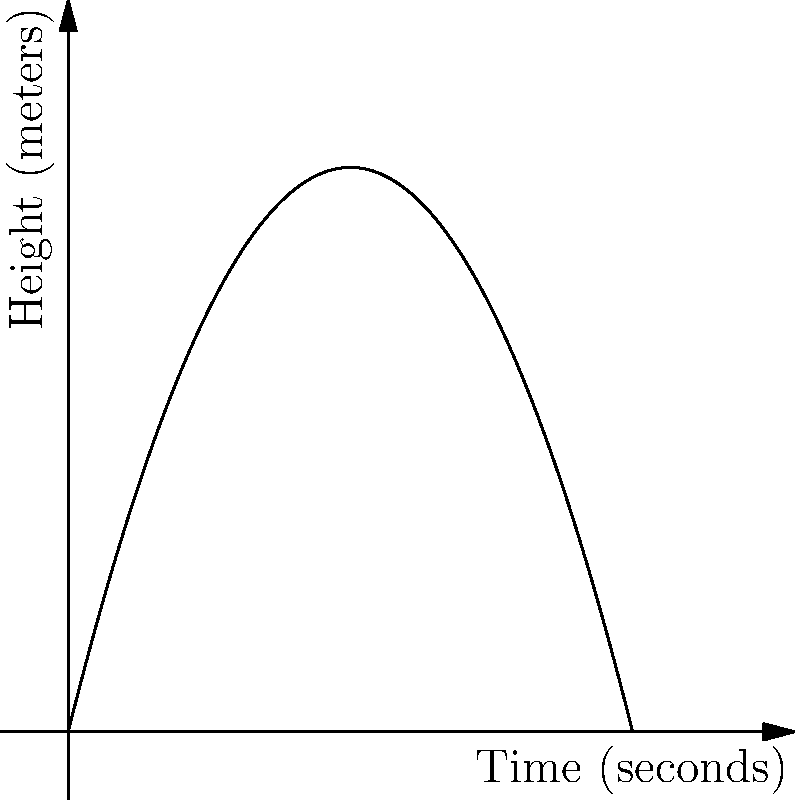During a karaoke performance, you dramatically throw your vintage microphone straight up into the air. The trajectory of the microphone can be modeled by the function $h(t) = -0.5t^2 + 4t$, where $h$ is the height in meters and $t$ is the time in seconds. How long does it take for the microphone to return to your hand, assuming you catch it at the same height you threw it? Let's approach this step-by-step:

1) The microphone returns to the starting height when $h(t) = 0$. So we need to solve the equation:

   $-0.5t^2 + 4t = 0$

2) Factor out the common factor $t$:

   $t(-0.5t + 4) = 0$

3) Use the zero product property. Either $t = 0$ or $-0.5t + 4 = 0$

4) We know $t = 0$ is the starting point when the microphone is thrown. We're interested in when it returns, so let's solve $-0.5t + 4 = 0$

5) Add 0.5t to both sides:
   
   $4 = 0.5t$

6) Multiply both sides by 2:

   $8 = t$

Therefore, it takes 8 seconds for the microphone to return to your hand.
Answer: 8 seconds 